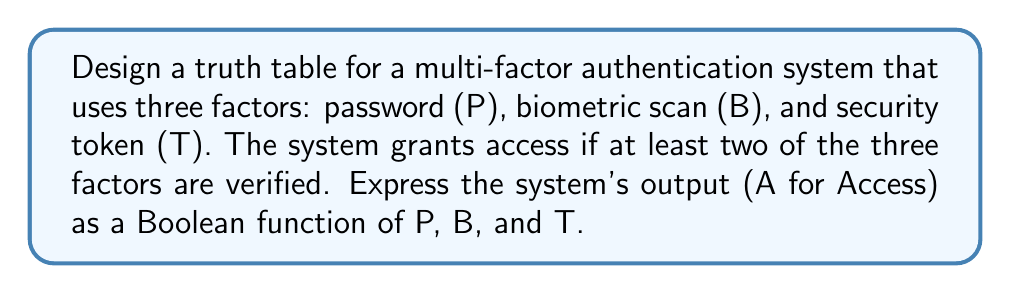Teach me how to tackle this problem. To solve this problem, we'll follow these steps:

1. Identify the inputs and output:
   Inputs: P (Password), B (Biometric scan), T (Security token)
   Output: A (Access)

2. Create a truth table with all possible combinations of inputs:
   $$
   \begin{array}{|c|c|c|c|}
   \hline
   P & B & T & A \\
   \hline
   0 & 0 & 0 & 0 \\
   0 & 0 & 1 & 0 \\
   0 & 1 & 0 & 0 \\
   0 & 1 & 1 & 1 \\
   1 & 0 & 0 & 0 \\
   1 & 0 & 1 & 1 \\
   1 & 1 & 0 & 1 \\
   1 & 1 & 1 & 1 \\
   \hline
   \end{array}
   $$

3. Identify the combinations where access is granted (A = 1):
   - When P = 0, B = 1, T = 1
   - When P = 1, B = 0, T = 1
   - When P = 1, B = 1, T = 0
   - When P = 1, B = 1, T = 1

4. Write the Boolean function using the sum of products (SOP) form:
   $A = \overline{P}BT + P\overline{B}T + PB\overline{T} + PBT$

5. Simplify the Boolean function:
   $A = \overline{P}BT + P\overline{B}T + PB\overline{T} + PBT$
   $A = BT + PT + PB$

6. Express the final Boolean function:
   $A = BT + PT + PB$

This Boolean function represents the multi-factor authentication system that grants access when at least two of the three factors are verified.
Answer: $A = BT + PT + PB$ 